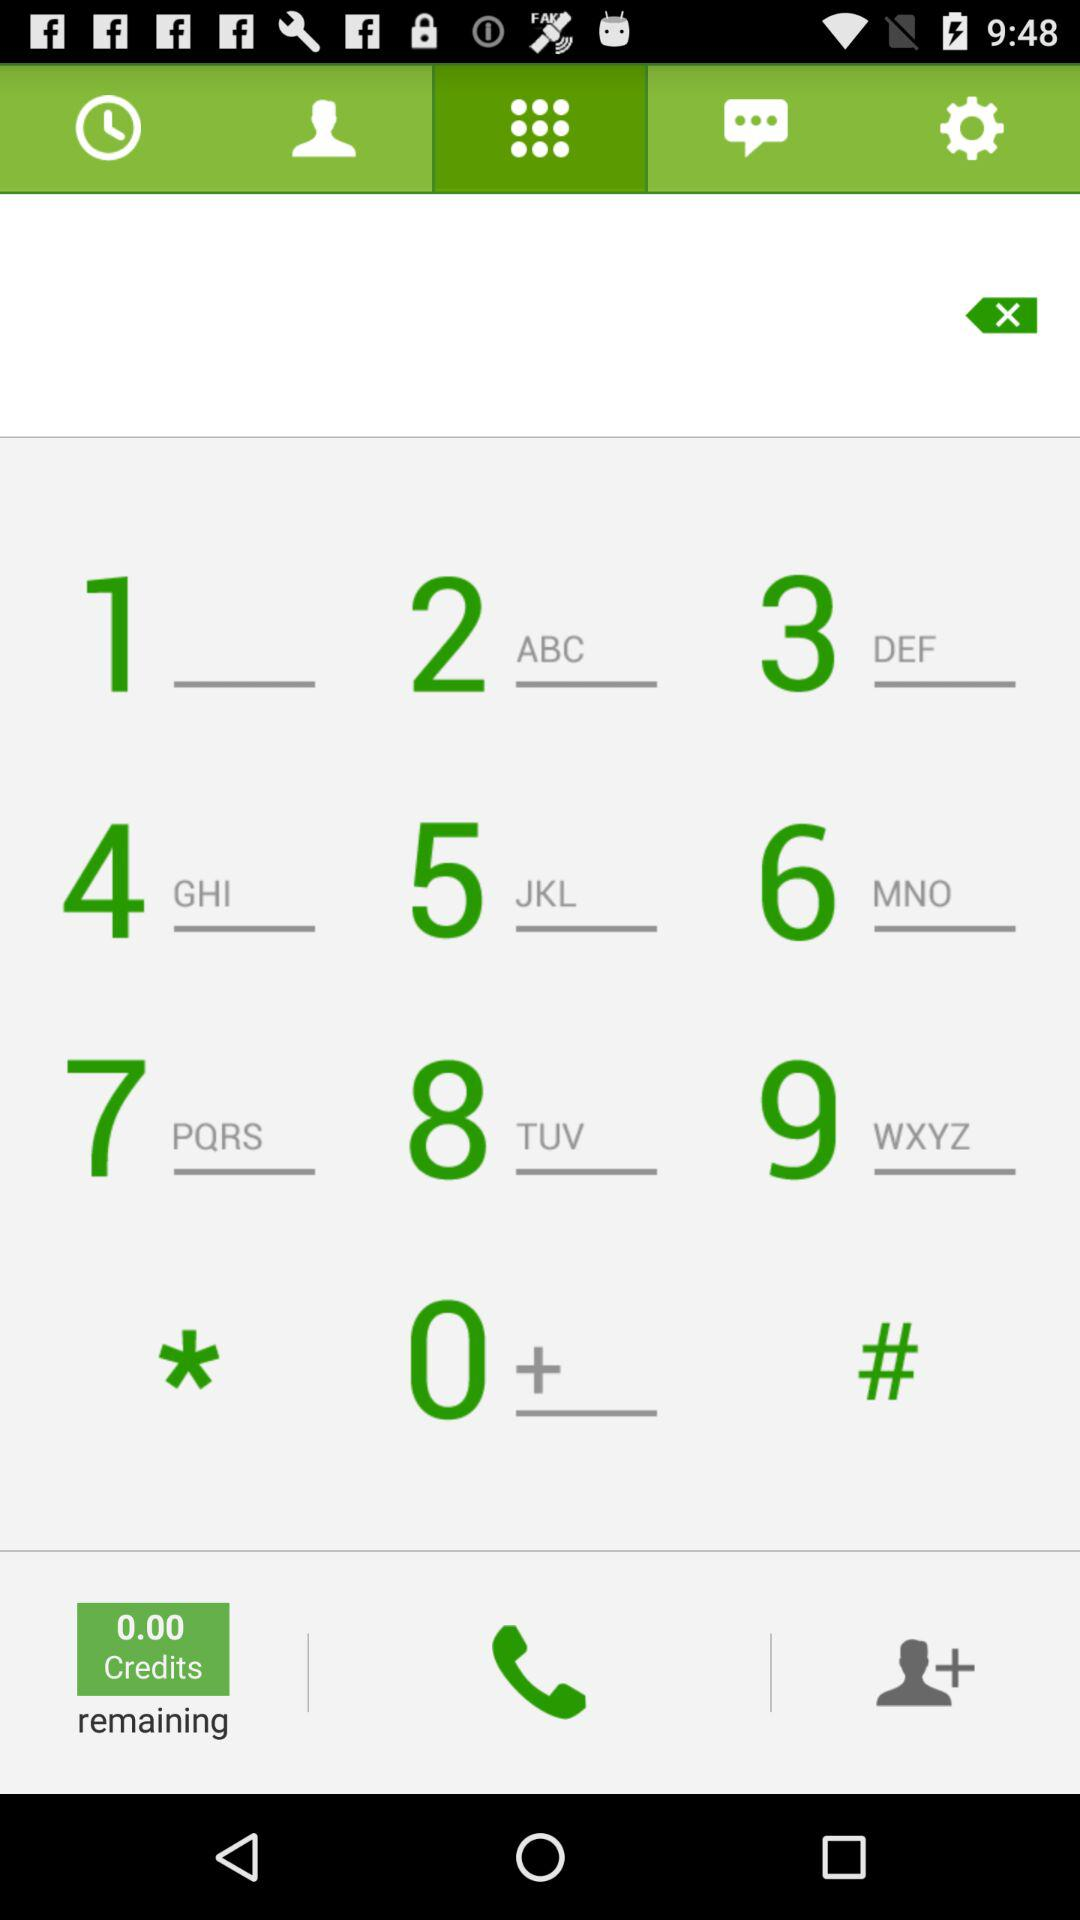Which tab is currently selected? The currently selected is "Dial pad". 